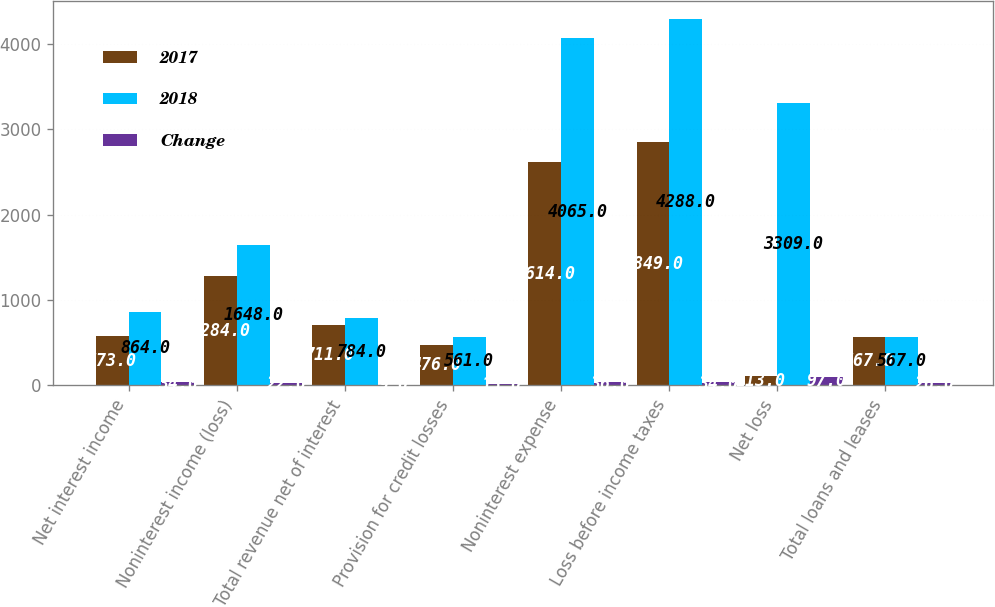Convert chart. <chart><loc_0><loc_0><loc_500><loc_500><stacked_bar_chart><ecel><fcel>Net interest income<fcel>Noninterest income (loss)<fcel>Total revenue net of interest<fcel>Provision for credit losses<fcel>Noninterest expense<fcel>Loss before income taxes<fcel>Net loss<fcel>Total loans and leases<nl><fcel>2017<fcel>573<fcel>1284<fcel>711<fcel>476<fcel>2614<fcel>2849<fcel>113<fcel>567<nl><fcel>2018<fcel>864<fcel>1648<fcel>784<fcel>561<fcel>4065<fcel>4288<fcel>3309<fcel>567<nl><fcel>Change<fcel>34<fcel>22<fcel>9<fcel>15<fcel>36<fcel>34<fcel>97<fcel>26<nl></chart> 